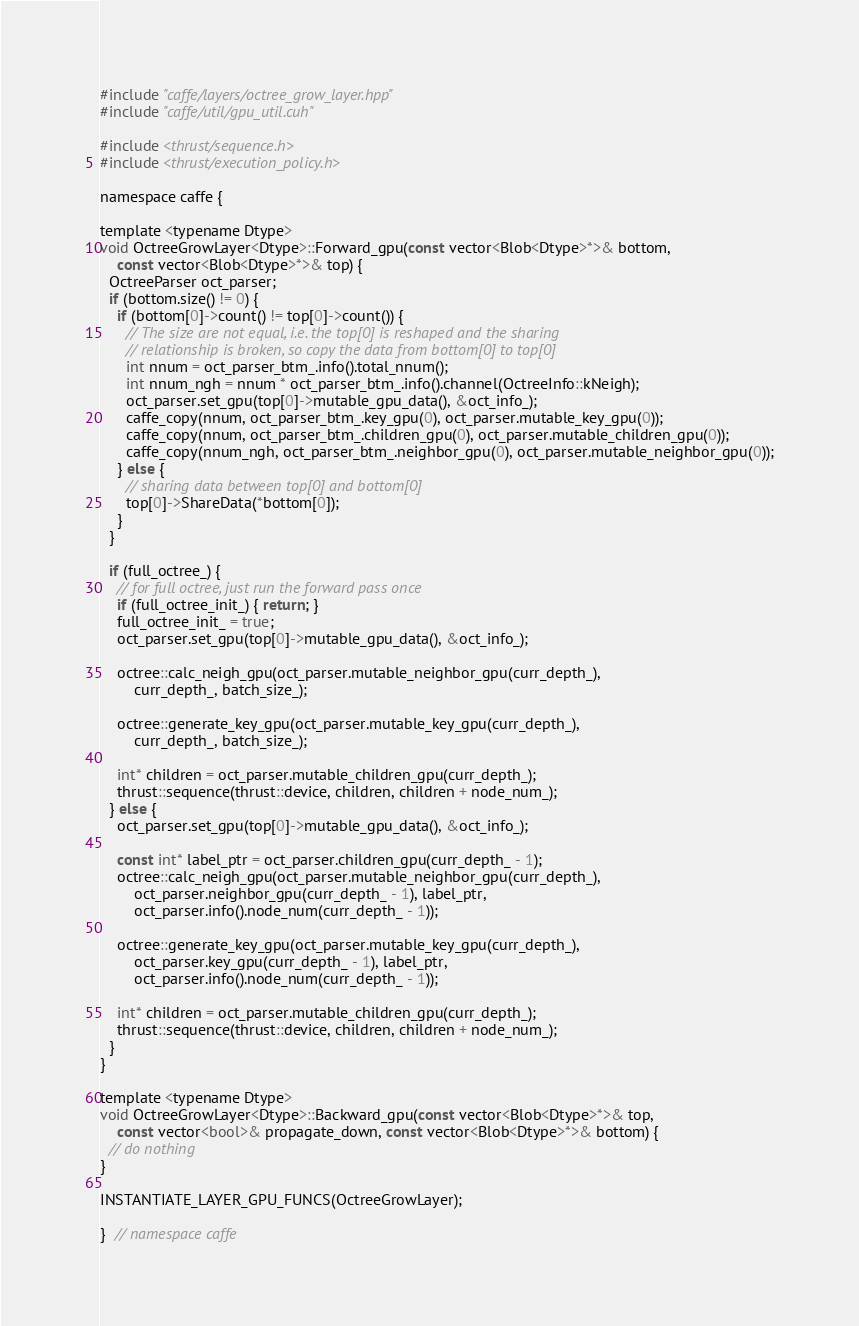Convert code to text. <code><loc_0><loc_0><loc_500><loc_500><_Cuda_>#include "caffe/layers/octree_grow_layer.hpp"
#include "caffe/util/gpu_util.cuh"

#include <thrust/sequence.h>
#include <thrust/execution_policy.h>

namespace caffe {

template <typename Dtype>
void OctreeGrowLayer<Dtype>::Forward_gpu(const vector<Blob<Dtype>*>& bottom,
    const vector<Blob<Dtype>*>& top) {
  OctreeParser oct_parser;
  if (bottom.size() != 0) {
    if (bottom[0]->count() != top[0]->count()) {
      // The size are not equal, i.e. the top[0] is reshaped and the sharing
      // relationship is broken, so copy the data from bottom[0] to top[0]
      int nnum = oct_parser_btm_.info().total_nnum();
      int nnum_ngh = nnum * oct_parser_btm_.info().channel(OctreeInfo::kNeigh);
      oct_parser.set_gpu(top[0]->mutable_gpu_data(), &oct_info_);
      caffe_copy(nnum, oct_parser_btm_.key_gpu(0), oct_parser.mutable_key_gpu(0));
      caffe_copy(nnum, oct_parser_btm_.children_gpu(0), oct_parser.mutable_children_gpu(0));
      caffe_copy(nnum_ngh, oct_parser_btm_.neighbor_gpu(0), oct_parser.mutable_neighbor_gpu(0));
    } else {
      // sharing data between top[0] and bottom[0]
      top[0]->ShareData(*bottom[0]);
    }
  }

  if (full_octree_) {
    // for full octree, just run the forward pass once
    if (full_octree_init_) { return; }
    full_octree_init_ = true;
    oct_parser.set_gpu(top[0]->mutable_gpu_data(), &oct_info_);

    octree::calc_neigh_gpu(oct_parser.mutable_neighbor_gpu(curr_depth_),
        curr_depth_, batch_size_);

    octree::generate_key_gpu(oct_parser.mutable_key_gpu(curr_depth_),
        curr_depth_, batch_size_);

    int* children = oct_parser.mutable_children_gpu(curr_depth_);
    thrust::sequence(thrust::device, children, children + node_num_);
  } else {
    oct_parser.set_gpu(top[0]->mutable_gpu_data(), &oct_info_);

    const int* label_ptr = oct_parser.children_gpu(curr_depth_ - 1);
    octree::calc_neigh_gpu(oct_parser.mutable_neighbor_gpu(curr_depth_),
        oct_parser.neighbor_gpu(curr_depth_ - 1), label_ptr,
        oct_parser.info().node_num(curr_depth_ - 1));

    octree::generate_key_gpu(oct_parser.mutable_key_gpu(curr_depth_),
        oct_parser.key_gpu(curr_depth_ - 1), label_ptr,
        oct_parser.info().node_num(curr_depth_ - 1));

    int* children = oct_parser.mutable_children_gpu(curr_depth_);
    thrust::sequence(thrust::device, children, children + node_num_);
  }
}

template <typename Dtype>
void OctreeGrowLayer<Dtype>::Backward_gpu(const vector<Blob<Dtype>*>& top,
    const vector<bool>& propagate_down, const vector<Blob<Dtype>*>& bottom) {
  // do nothing
}

INSTANTIATE_LAYER_GPU_FUNCS(OctreeGrowLayer);

}  // namespace caffe</code> 